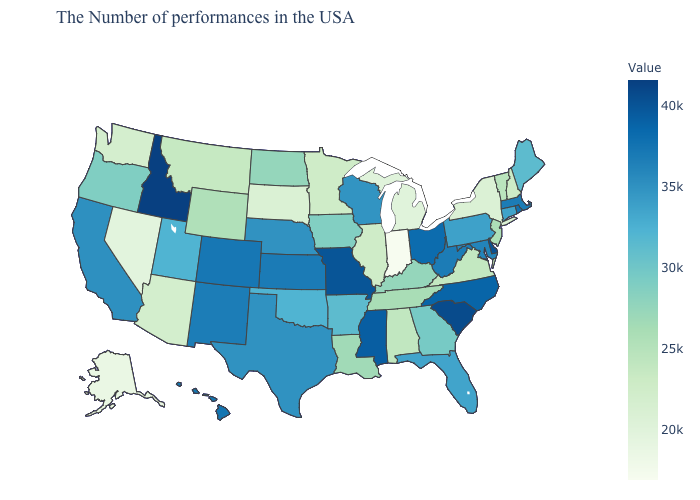Does Utah have the lowest value in the West?
Write a very short answer. No. Which states have the highest value in the USA?
Be succinct. Idaho. Does the map have missing data?
Keep it brief. No. Does New Jersey have the lowest value in the USA?
Quick response, please. No. Among the states that border Wisconsin , which have the highest value?
Be succinct. Iowa. Does Virginia have the lowest value in the South?
Be succinct. Yes. 